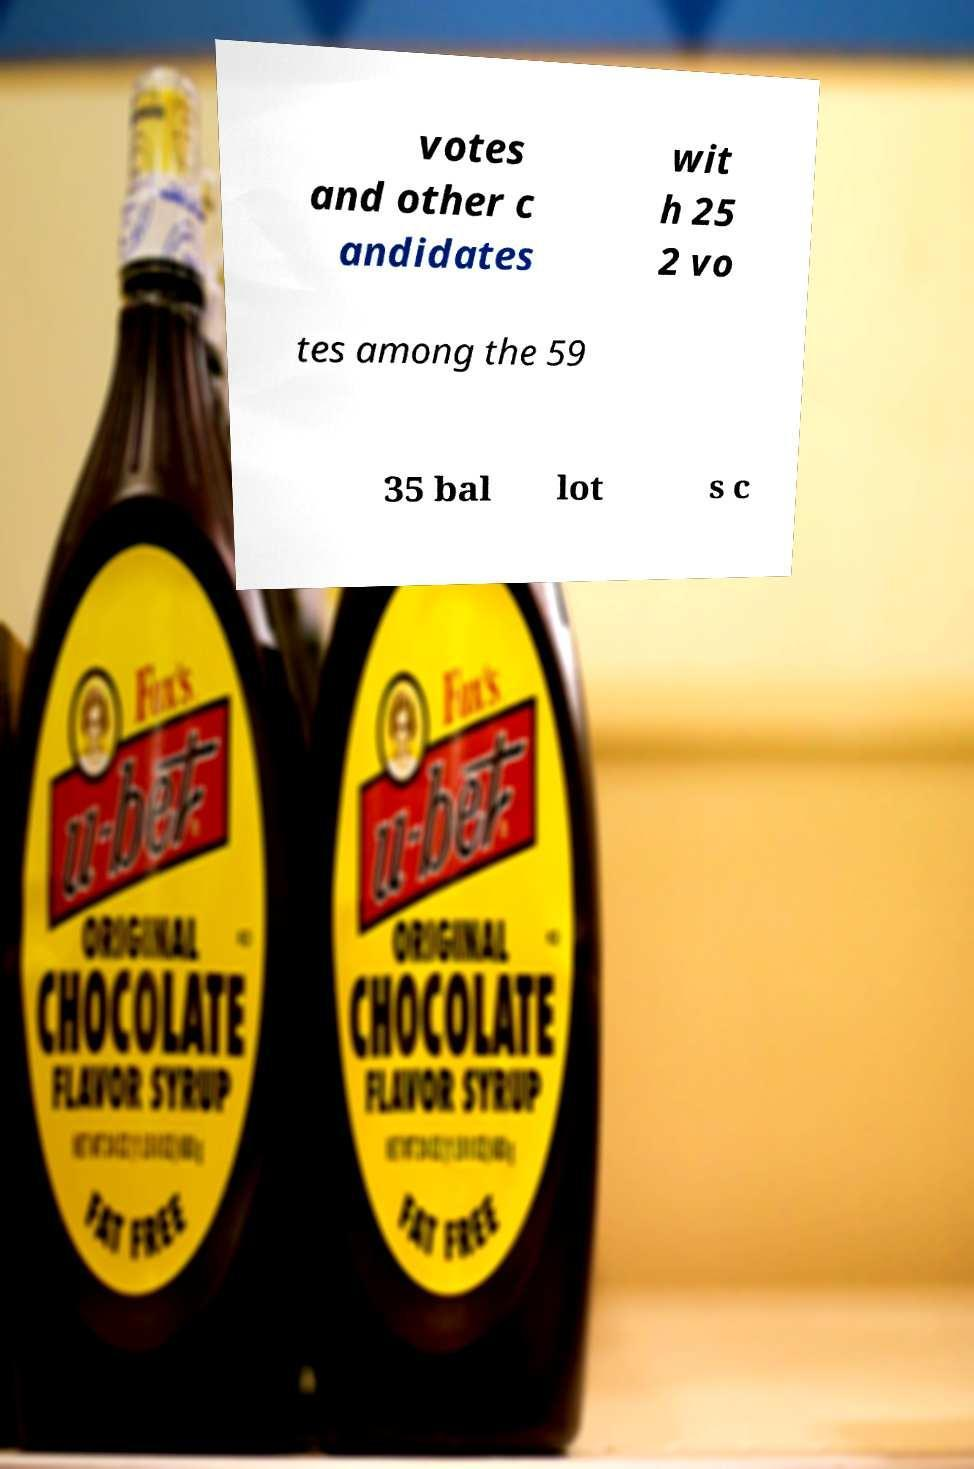Can you accurately transcribe the text from the provided image for me? votes and other c andidates wit h 25 2 vo tes among the 59 35 bal lot s c 